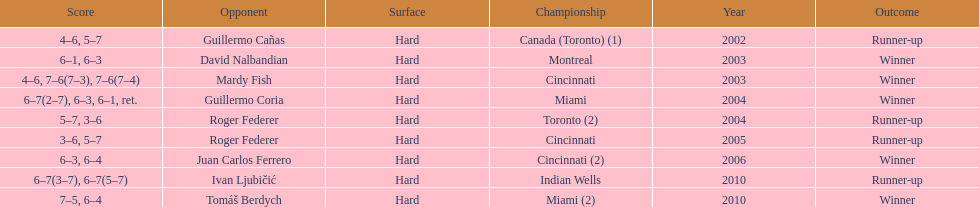How many instances has he been the second-place finisher? 4. 